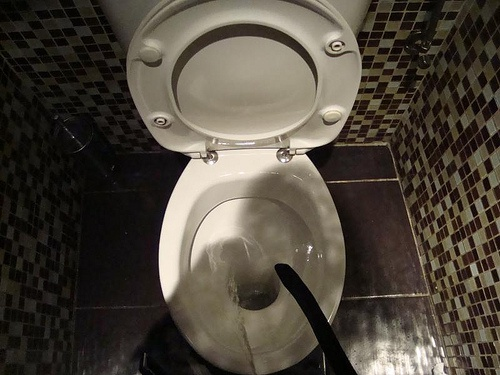Describe the objects in this image and their specific colors. I can see a toilet in black, gray, darkgray, and ivory tones in this image. 